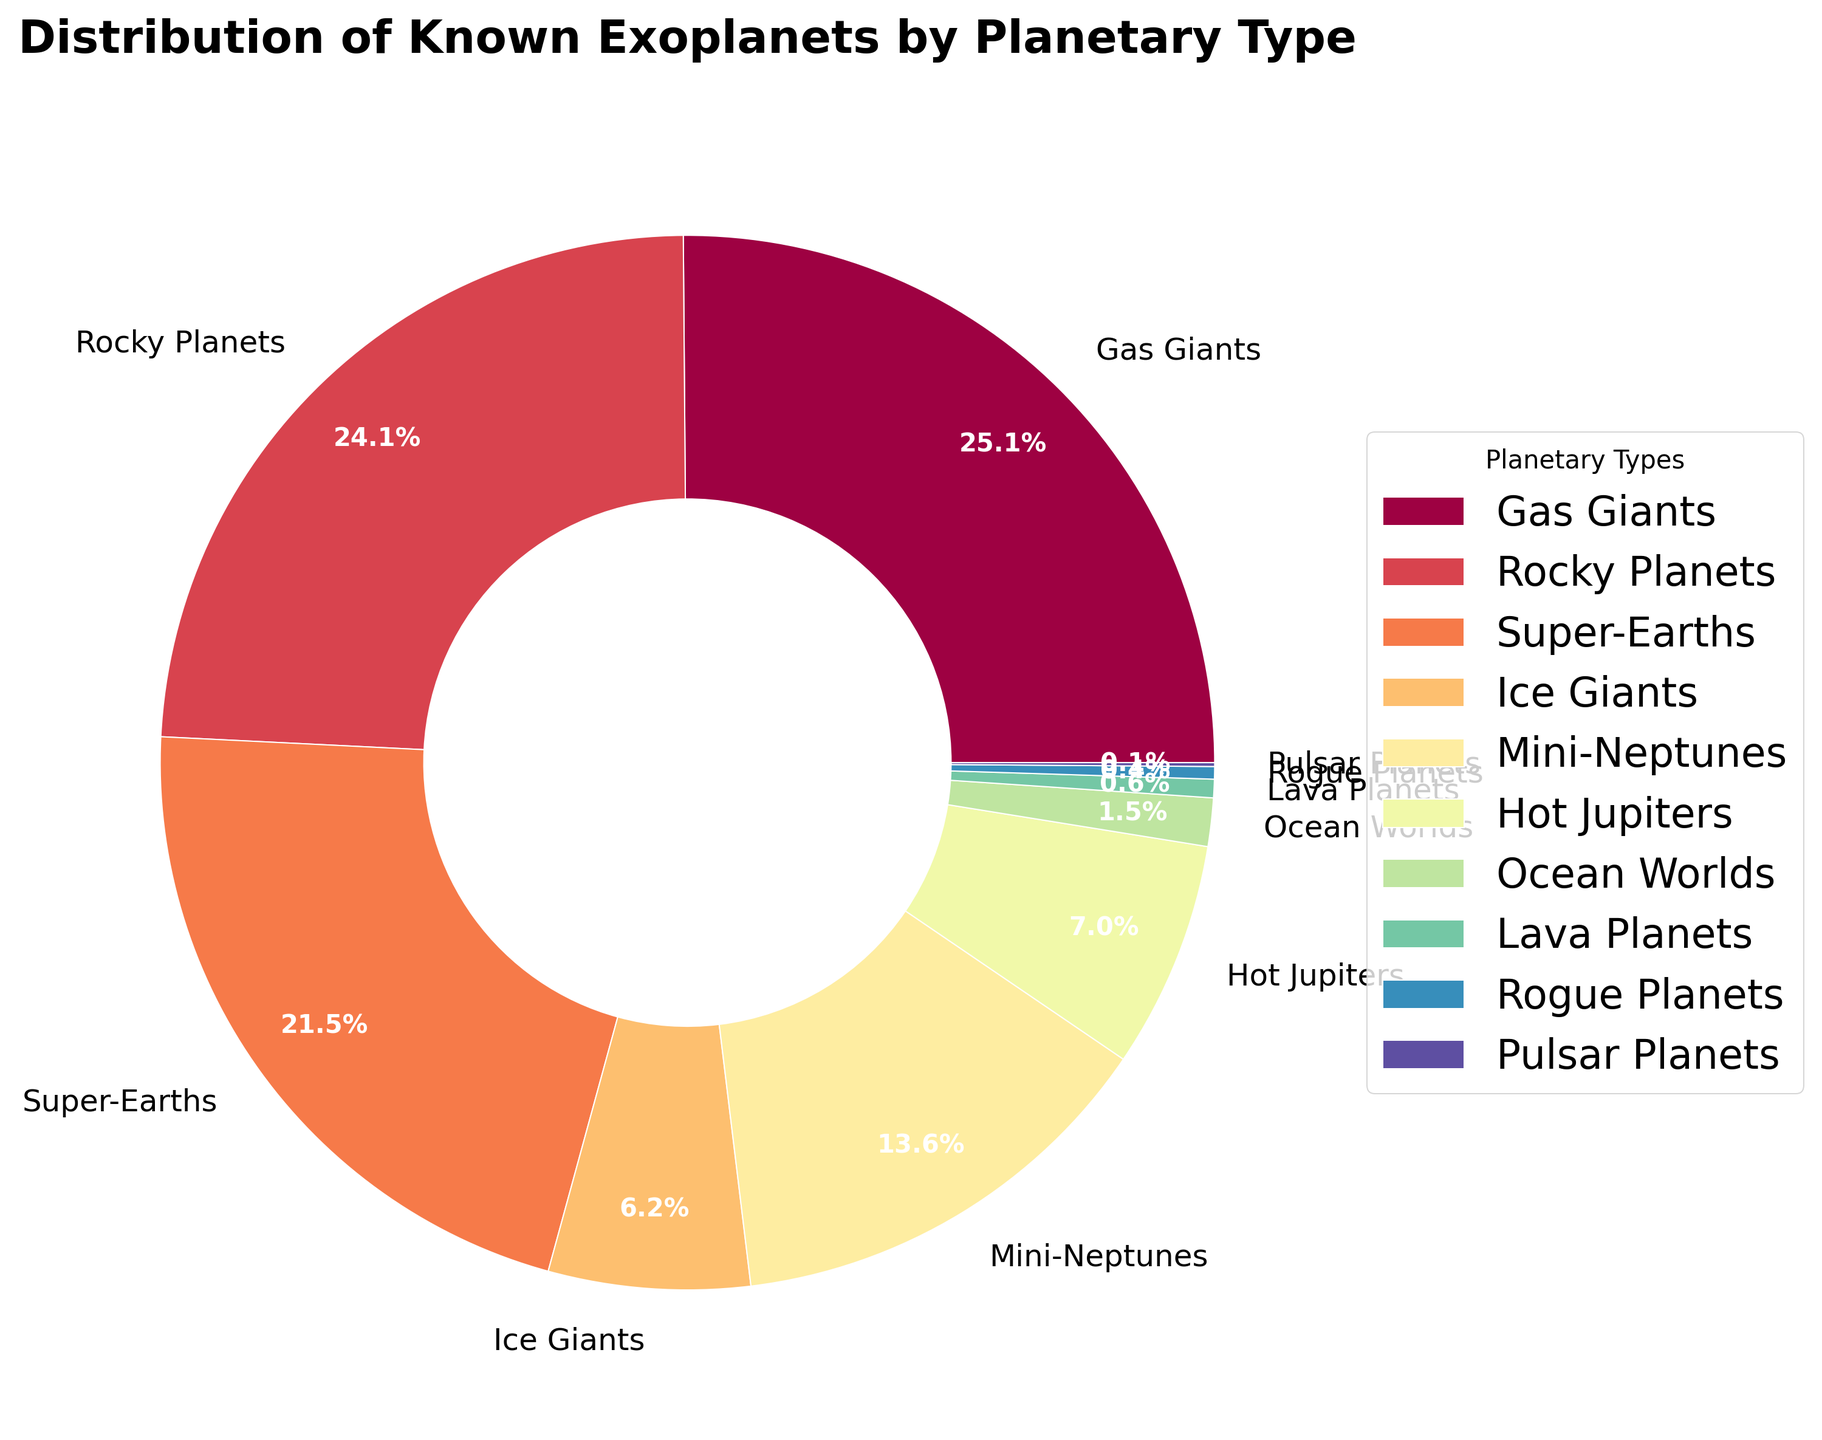Which planetary type has the largest number of known exoplanets? The size of each segment in the pie chart represents the count of each planetary type. The Gas Giants segment is the largest.
Answer: Gas Giants Which planetary type has the smallest number of known exoplanets? The size of each segment in the pie chart represents the count of each planetary type. The Pulsar Planets segment is the smallest.
Answer: Pulsar Planets How many more Gas Giants are there than Hot Jupiters? From the pie chart, we see the counts for Gas Giants and Hot Jupiters as 1509 and 418, respectively. The difference is \(1509 - 418\).
Answer: 1091 What is the combined percentage of known exoplanets that are Ice Giants and Lava Planets? The pie chart shows 371 Ice Giants and 34 Lava Planets. First, sum the counts: \(371 + 34 = 405\). Find the total: \(1509 + 1447 + 1293 + 371 + 815 + 418 + 89 + 34 + 23 + 7 = 6006\). The combined percentage is: \((405 / 6006) \times 100 \approx 6.7\% \).
Answer: 6.7% Which is more common: Mini-Neptunes or Super-Earths? The pie chart shows 815 Mini-Neptunes and 1293 Super-Earths. Comparing these values, Super-Earths are more common.
Answer: Super-Earths Are Rocky Planets more common than Gas Giants? The pie chart shows 1447 Rocky Planets and 1509 Gas Giants. Comparing these values, Gas Giants are more common.
Answer: No What planetary type represents about 6.2% of the known exoplanets? By examining the percentages on the pie chart, Mini-Neptunes occupy about 6.2%.
Answer: Mini-Neptunes What is the combined count of Rogue Planets, Ocean Worlds, and Lava Planets? The Rogue Planets count is 23, Ocean Worlds count is 89, and Lava Planets count is 34. Summing these values: \(23 + 89 + 34 = 146\).
Answer: 146 What is the percentage difference between Hot Jupiters and Ice Giants? From the pie chart, Hot Jupiters are 418 and Ice Giants are 371. Total exoplanets count is 6006. Percentages are: \((418 / 6006) \times 100 \approx 7\% and (371 / 6006) \times 100 \approx 6.2\%\). The difference in percentage is \(7\% - 6.2\% = 0.8\% \).
Answer: 0.8% 